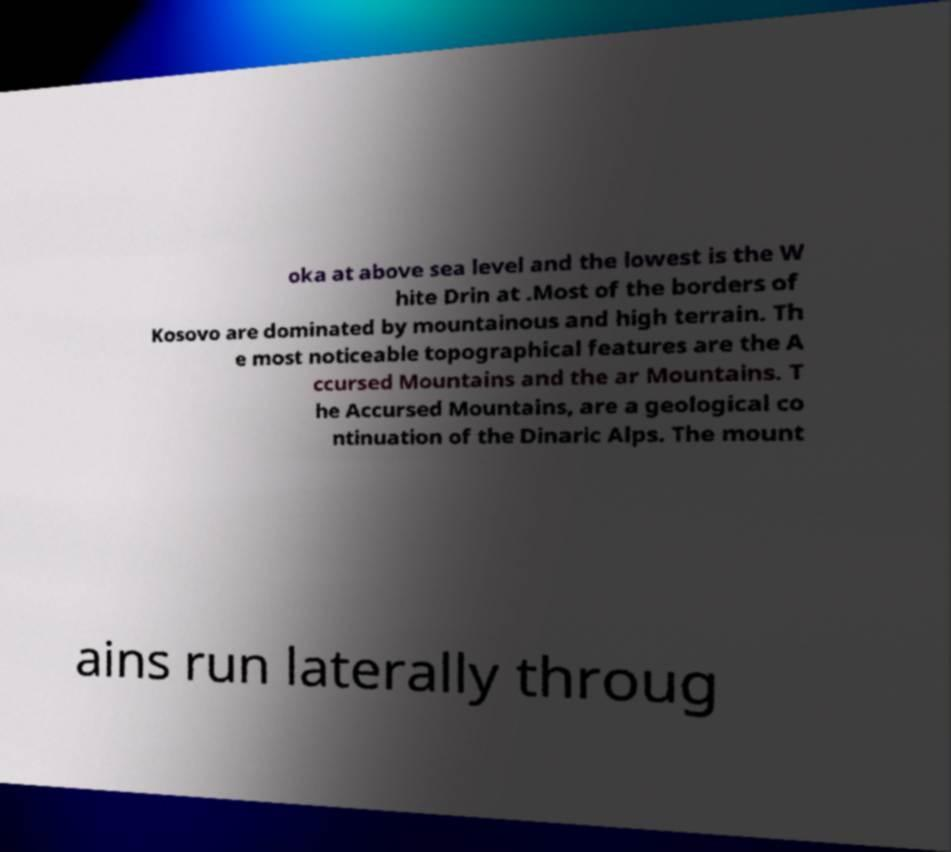I need the written content from this picture converted into text. Can you do that? oka at above sea level and the lowest is the W hite Drin at .Most of the borders of Kosovo are dominated by mountainous and high terrain. Th e most noticeable topographical features are the A ccursed Mountains and the ar Mountains. T he Accursed Mountains, are a geological co ntinuation of the Dinaric Alps. The mount ains run laterally throug 